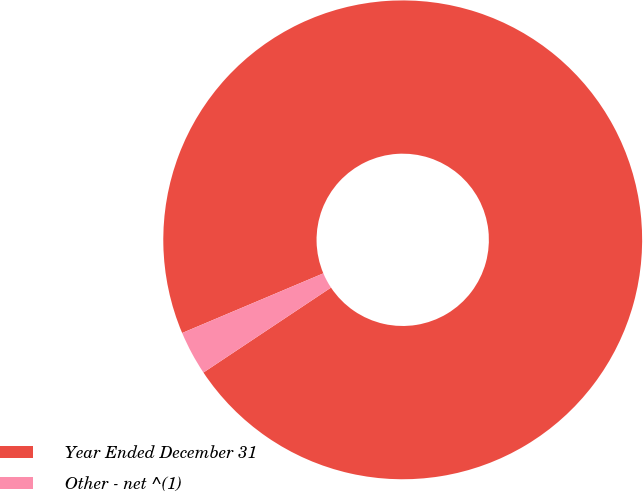<chart> <loc_0><loc_0><loc_500><loc_500><pie_chart><fcel>Year Ended December 31<fcel>Other - net ^(1)<nl><fcel>97.01%<fcel>2.99%<nl></chart> 